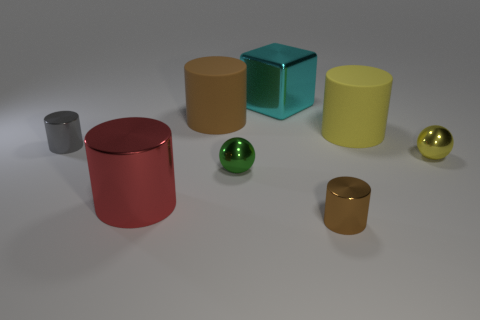Is there any other thing that is the same color as the big metal cylinder?
Offer a very short reply. No. There is a brown cylinder that is to the left of the brown object in front of the red shiny cylinder; how big is it?
Your answer should be compact. Large. What is the color of the shiny thing that is behind the red cylinder and to the right of the cyan thing?
Make the answer very short. Yellow. How many other objects are there of the same size as the red thing?
Provide a short and direct response. 3. Do the red shiny thing and the brown object behind the large metal cylinder have the same size?
Provide a short and direct response. Yes. What color is the shiny sphere that is the same size as the green metal thing?
Your answer should be very brief. Yellow. The brown shiny object has what size?
Your answer should be very brief. Small. Is the material of the yellow object that is behind the tiny yellow sphere the same as the small yellow thing?
Offer a terse response. No. Does the small gray metallic object have the same shape as the small brown metal object?
Provide a succinct answer. Yes. What shape is the matte object that is on the right side of the metal object that is behind the big rubber cylinder left of the cyan object?
Make the answer very short. Cylinder. 